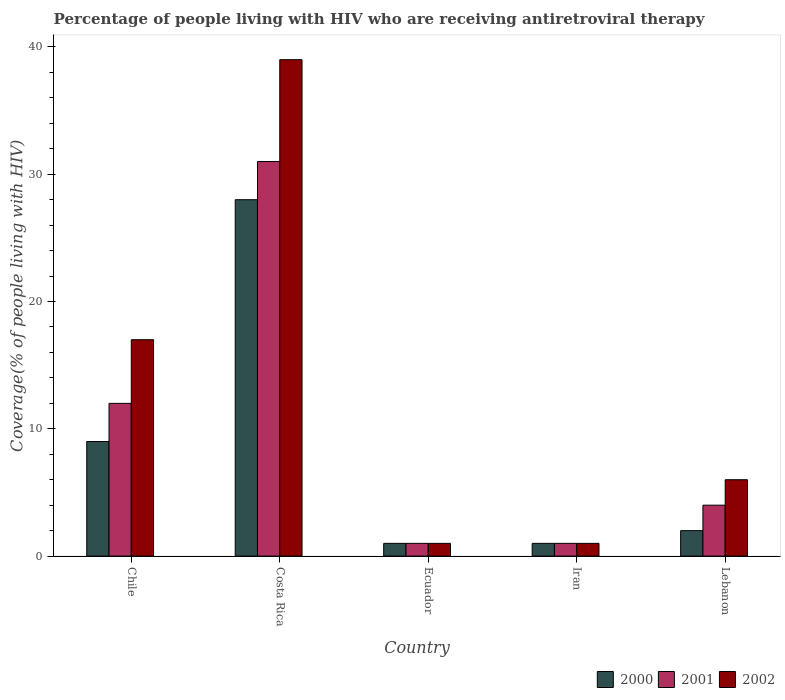How many different coloured bars are there?
Provide a short and direct response. 3. Are the number of bars per tick equal to the number of legend labels?
Provide a succinct answer. Yes. How many bars are there on the 1st tick from the right?
Your answer should be very brief. 3. What is the label of the 3rd group of bars from the left?
Provide a short and direct response. Ecuador. What is the percentage of the HIV infected people who are receiving antiretroviral therapy in 2002 in Lebanon?
Make the answer very short. 6. In which country was the percentage of the HIV infected people who are receiving antiretroviral therapy in 2002 maximum?
Offer a terse response. Costa Rica. In which country was the percentage of the HIV infected people who are receiving antiretroviral therapy in 2000 minimum?
Give a very brief answer. Ecuador. What is the difference between the percentage of the HIV infected people who are receiving antiretroviral therapy in 2002 in Iran and the percentage of the HIV infected people who are receiving antiretroviral therapy in 2000 in Ecuador?
Offer a very short reply. 0. In how many countries, is the percentage of the HIV infected people who are receiving antiretroviral therapy in 2001 greater than 4 %?
Provide a short and direct response. 2. What is the ratio of the percentage of the HIV infected people who are receiving antiretroviral therapy in 2001 in Costa Rica to that in Iran?
Ensure brevity in your answer.  31. What is the difference between the highest and the second highest percentage of the HIV infected people who are receiving antiretroviral therapy in 2002?
Keep it short and to the point. 11. What is the difference between the highest and the lowest percentage of the HIV infected people who are receiving antiretroviral therapy in 2000?
Your answer should be compact. 27. In how many countries, is the percentage of the HIV infected people who are receiving antiretroviral therapy in 2000 greater than the average percentage of the HIV infected people who are receiving antiretroviral therapy in 2000 taken over all countries?
Give a very brief answer. 2. What does the 3rd bar from the left in Chile represents?
Ensure brevity in your answer.  2002. How many bars are there?
Ensure brevity in your answer.  15. How many countries are there in the graph?
Ensure brevity in your answer.  5. Where does the legend appear in the graph?
Keep it short and to the point. Bottom right. How many legend labels are there?
Provide a succinct answer. 3. How are the legend labels stacked?
Your answer should be compact. Horizontal. What is the title of the graph?
Offer a very short reply. Percentage of people living with HIV who are receiving antiretroviral therapy. What is the label or title of the X-axis?
Give a very brief answer. Country. What is the label or title of the Y-axis?
Your answer should be very brief. Coverage(% of people living with HIV). What is the Coverage(% of people living with HIV) in 2000 in Chile?
Give a very brief answer. 9. What is the Coverage(% of people living with HIV) in 2002 in Chile?
Offer a very short reply. 17. What is the Coverage(% of people living with HIV) in 2000 in Costa Rica?
Make the answer very short. 28. What is the Coverage(% of people living with HIV) in 2002 in Costa Rica?
Give a very brief answer. 39. What is the Coverage(% of people living with HIV) of 2002 in Ecuador?
Provide a succinct answer. 1. What is the Coverage(% of people living with HIV) of 2001 in Iran?
Your answer should be compact. 1. What is the Coverage(% of people living with HIV) in 2001 in Lebanon?
Your answer should be compact. 4. Across all countries, what is the maximum Coverage(% of people living with HIV) in 2000?
Your answer should be very brief. 28. Across all countries, what is the maximum Coverage(% of people living with HIV) in 2001?
Ensure brevity in your answer.  31. Across all countries, what is the minimum Coverage(% of people living with HIV) of 2002?
Ensure brevity in your answer.  1. What is the total Coverage(% of people living with HIV) in 2001 in the graph?
Make the answer very short. 49. What is the difference between the Coverage(% of people living with HIV) of 2000 in Chile and that in Costa Rica?
Your answer should be very brief. -19. What is the difference between the Coverage(% of people living with HIV) in 2001 in Chile and that in Costa Rica?
Offer a very short reply. -19. What is the difference between the Coverage(% of people living with HIV) of 2002 in Chile and that in Costa Rica?
Make the answer very short. -22. What is the difference between the Coverage(% of people living with HIV) of 2000 in Chile and that in Ecuador?
Your answer should be very brief. 8. What is the difference between the Coverage(% of people living with HIV) of 2000 in Chile and that in Iran?
Your answer should be very brief. 8. What is the difference between the Coverage(% of people living with HIV) of 2000 in Chile and that in Lebanon?
Provide a succinct answer. 7. What is the difference between the Coverage(% of people living with HIV) of 2000 in Costa Rica and that in Ecuador?
Keep it short and to the point. 27. What is the difference between the Coverage(% of people living with HIV) of 2001 in Costa Rica and that in Ecuador?
Ensure brevity in your answer.  30. What is the difference between the Coverage(% of people living with HIV) in 2000 in Costa Rica and that in Iran?
Provide a succinct answer. 27. What is the difference between the Coverage(% of people living with HIV) of 2001 in Costa Rica and that in Iran?
Keep it short and to the point. 30. What is the difference between the Coverage(% of people living with HIV) in 2001 in Costa Rica and that in Lebanon?
Your answer should be very brief. 27. What is the difference between the Coverage(% of people living with HIV) of 2001 in Ecuador and that in Lebanon?
Provide a short and direct response. -3. What is the difference between the Coverage(% of people living with HIV) of 2000 in Iran and that in Lebanon?
Your answer should be compact. -1. What is the difference between the Coverage(% of people living with HIV) in 2001 in Iran and that in Lebanon?
Ensure brevity in your answer.  -3. What is the difference between the Coverage(% of people living with HIV) of 2002 in Iran and that in Lebanon?
Provide a short and direct response. -5. What is the difference between the Coverage(% of people living with HIV) in 2000 in Chile and the Coverage(% of people living with HIV) in 2002 in Costa Rica?
Provide a short and direct response. -30. What is the difference between the Coverage(% of people living with HIV) of 2001 in Chile and the Coverage(% of people living with HIV) of 2002 in Ecuador?
Offer a very short reply. 11. What is the difference between the Coverage(% of people living with HIV) in 2000 in Chile and the Coverage(% of people living with HIV) in 2002 in Lebanon?
Provide a succinct answer. 3. What is the difference between the Coverage(% of people living with HIV) of 2000 in Costa Rica and the Coverage(% of people living with HIV) of 2001 in Iran?
Your response must be concise. 27. What is the difference between the Coverage(% of people living with HIV) in 2001 in Costa Rica and the Coverage(% of people living with HIV) in 2002 in Iran?
Ensure brevity in your answer.  30. What is the difference between the Coverage(% of people living with HIV) of 2000 in Ecuador and the Coverage(% of people living with HIV) of 2001 in Iran?
Your answer should be compact. 0. What is the difference between the Coverage(% of people living with HIV) in 2000 in Ecuador and the Coverage(% of people living with HIV) in 2002 in Iran?
Give a very brief answer. 0. What is the difference between the Coverage(% of people living with HIV) of 2001 in Ecuador and the Coverage(% of people living with HIV) of 2002 in Iran?
Offer a very short reply. 0. What is the difference between the Coverage(% of people living with HIV) in 2000 in Ecuador and the Coverage(% of people living with HIV) in 2001 in Lebanon?
Ensure brevity in your answer.  -3. What is the difference between the Coverage(% of people living with HIV) of 2001 in Ecuador and the Coverage(% of people living with HIV) of 2002 in Lebanon?
Give a very brief answer. -5. What is the average Coverage(% of people living with HIV) of 2001 per country?
Keep it short and to the point. 9.8. What is the difference between the Coverage(% of people living with HIV) of 2000 and Coverage(% of people living with HIV) of 2001 in Chile?
Provide a short and direct response. -3. What is the difference between the Coverage(% of people living with HIV) of 2000 and Coverage(% of people living with HIV) of 2002 in Costa Rica?
Give a very brief answer. -11. What is the difference between the Coverage(% of people living with HIV) in 2000 and Coverage(% of people living with HIV) in 2001 in Ecuador?
Your answer should be compact. 0. What is the difference between the Coverage(% of people living with HIV) in 2000 and Coverage(% of people living with HIV) in 2002 in Ecuador?
Keep it short and to the point. 0. What is the difference between the Coverage(% of people living with HIV) of 2000 and Coverage(% of people living with HIV) of 2001 in Iran?
Offer a very short reply. 0. What is the difference between the Coverage(% of people living with HIV) of 2001 and Coverage(% of people living with HIV) of 2002 in Iran?
Your answer should be compact. 0. What is the difference between the Coverage(% of people living with HIV) of 2000 and Coverage(% of people living with HIV) of 2001 in Lebanon?
Offer a very short reply. -2. What is the difference between the Coverage(% of people living with HIV) of 2000 and Coverage(% of people living with HIV) of 2002 in Lebanon?
Offer a terse response. -4. What is the ratio of the Coverage(% of people living with HIV) of 2000 in Chile to that in Costa Rica?
Provide a short and direct response. 0.32. What is the ratio of the Coverage(% of people living with HIV) of 2001 in Chile to that in Costa Rica?
Make the answer very short. 0.39. What is the ratio of the Coverage(% of people living with HIV) in 2002 in Chile to that in Costa Rica?
Your answer should be very brief. 0.44. What is the ratio of the Coverage(% of people living with HIV) in 2001 in Chile to that in Ecuador?
Provide a short and direct response. 12. What is the ratio of the Coverage(% of people living with HIV) in 2001 in Chile to that in Iran?
Offer a very short reply. 12. What is the ratio of the Coverage(% of people living with HIV) of 2002 in Chile to that in Lebanon?
Give a very brief answer. 2.83. What is the ratio of the Coverage(% of people living with HIV) of 2000 in Costa Rica to that in Ecuador?
Make the answer very short. 28. What is the ratio of the Coverage(% of people living with HIV) of 2002 in Costa Rica to that in Ecuador?
Offer a very short reply. 39. What is the ratio of the Coverage(% of people living with HIV) of 2001 in Costa Rica to that in Iran?
Provide a succinct answer. 31. What is the ratio of the Coverage(% of people living with HIV) in 2002 in Costa Rica to that in Iran?
Make the answer very short. 39. What is the ratio of the Coverage(% of people living with HIV) in 2000 in Costa Rica to that in Lebanon?
Provide a succinct answer. 14. What is the ratio of the Coverage(% of people living with HIV) of 2001 in Costa Rica to that in Lebanon?
Your answer should be very brief. 7.75. What is the ratio of the Coverage(% of people living with HIV) of 2000 in Ecuador to that in Iran?
Your response must be concise. 1. What is the ratio of the Coverage(% of people living with HIV) of 2001 in Ecuador to that in Iran?
Make the answer very short. 1. What is the ratio of the Coverage(% of people living with HIV) in 2002 in Ecuador to that in Lebanon?
Your response must be concise. 0.17. What is the difference between the highest and the lowest Coverage(% of people living with HIV) in 2000?
Ensure brevity in your answer.  27. What is the difference between the highest and the lowest Coverage(% of people living with HIV) of 2001?
Ensure brevity in your answer.  30. What is the difference between the highest and the lowest Coverage(% of people living with HIV) in 2002?
Provide a succinct answer. 38. 